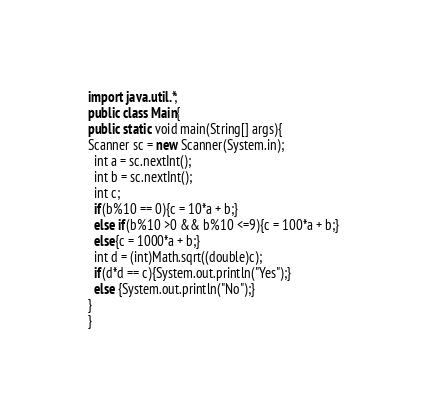Convert code to text. <code><loc_0><loc_0><loc_500><loc_500><_Java_>import java.util.*;
public class Main{
public static void main(String[] args){
Scanner sc = new Scanner(System.in);
  int a = sc.nextInt();
  int b = sc.nextInt();
  int c;
  if(b%10 == 0){c = 10*a + b;}
  else if(b%10 >0 && b%10 <=9){c = 100*a + b;}
  else{c = 1000*a + b;}
  int d = (int)Math.sqrt((double)c);
  if(d*d == c){System.out.println("Yes");}
  else {System.out.println("No");}
}
}
</code> 